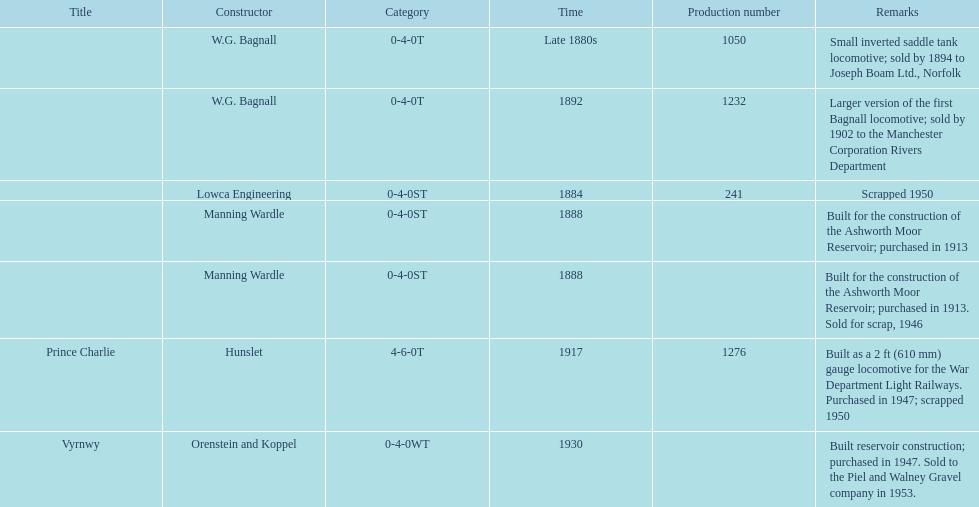How many locomotives were built before the 1900s? 5. 